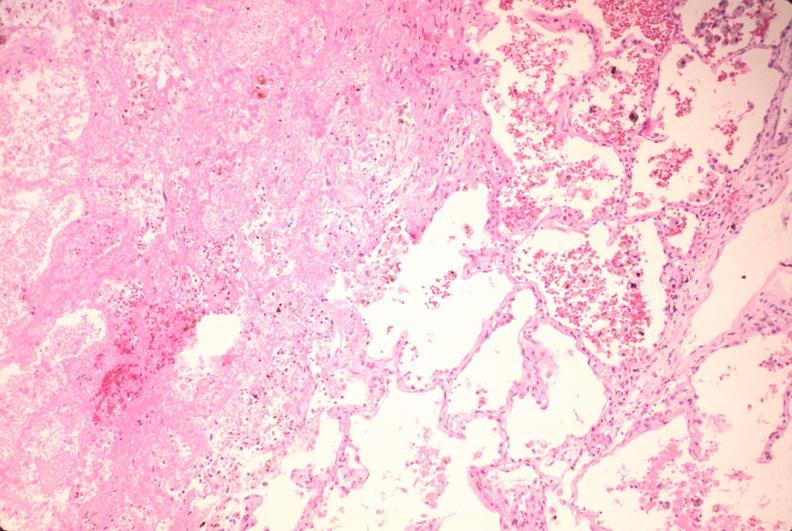what is present?
Answer the question using a single word or phrase. Respiratory 